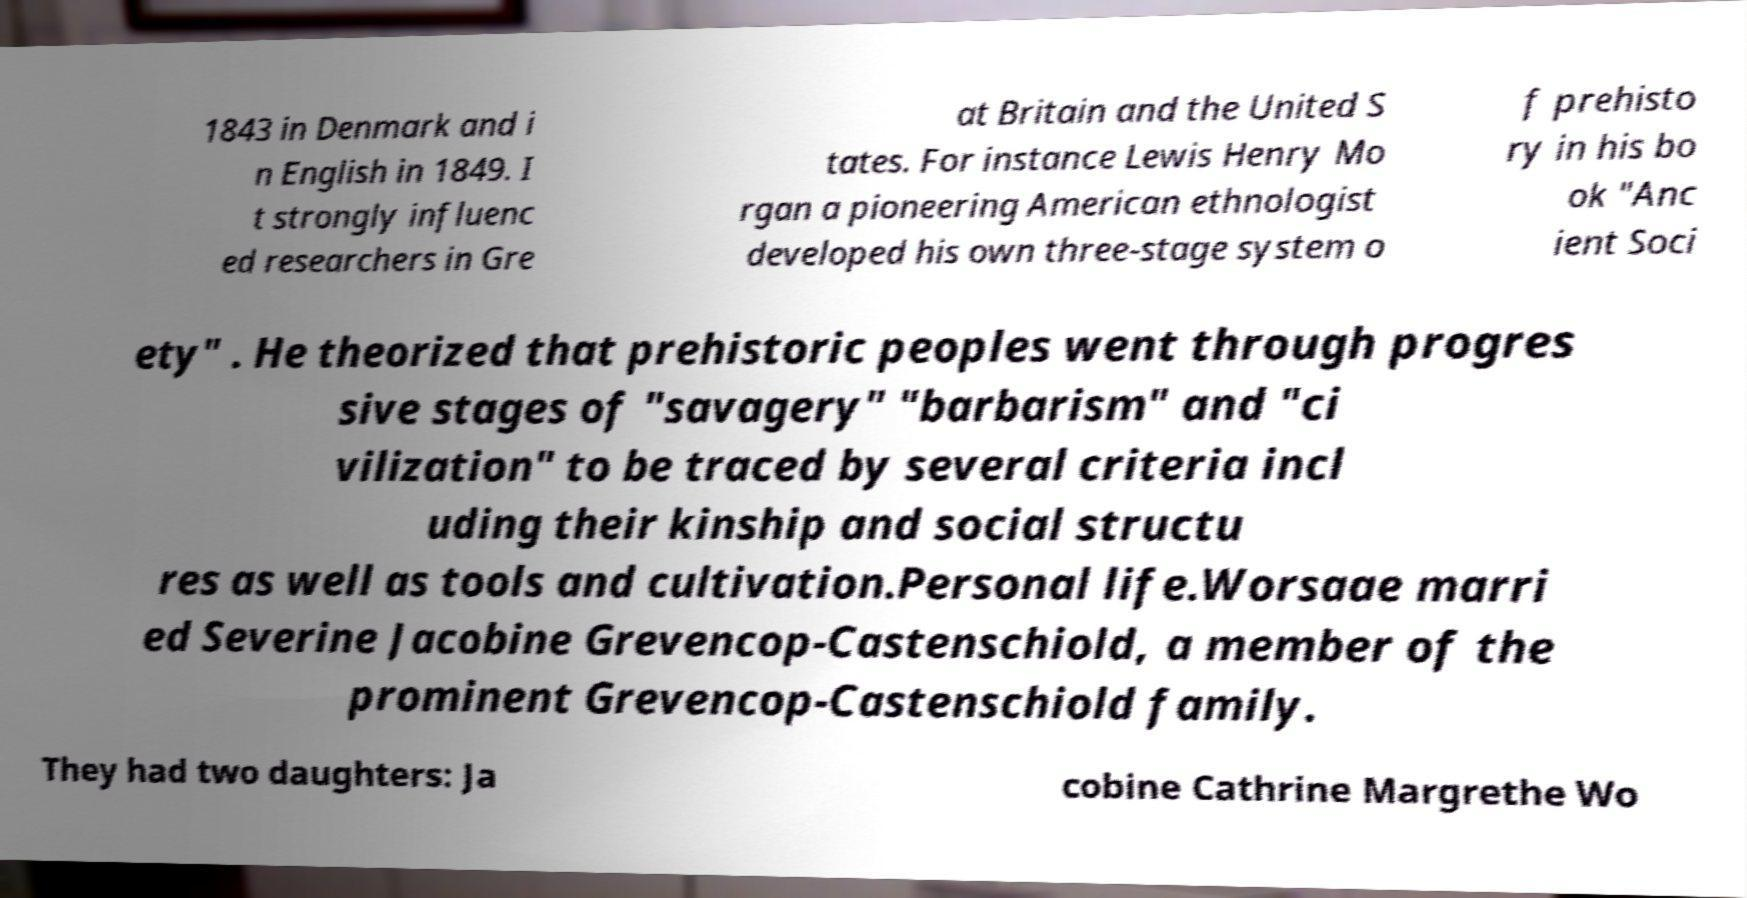Could you extract and type out the text from this image? 1843 in Denmark and i n English in 1849. I t strongly influenc ed researchers in Gre at Britain and the United S tates. For instance Lewis Henry Mo rgan a pioneering American ethnologist developed his own three-stage system o f prehisto ry in his bo ok "Anc ient Soci ety" . He theorized that prehistoric peoples went through progres sive stages of "savagery" "barbarism" and "ci vilization" to be traced by several criteria incl uding their kinship and social structu res as well as tools and cultivation.Personal life.Worsaae marri ed Severine Jacobine Grevencop-Castenschiold, a member of the prominent Grevencop-Castenschiold family. They had two daughters: Ja cobine Cathrine Margrethe Wo 